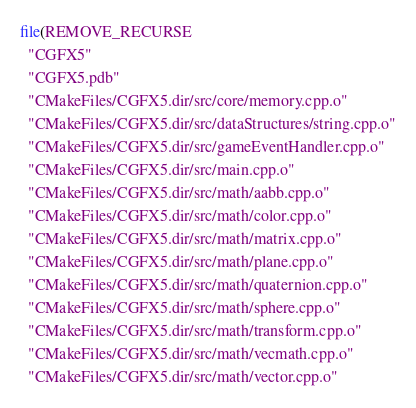Convert code to text. <code><loc_0><loc_0><loc_500><loc_500><_CMake_>file(REMOVE_RECURSE
  "CGFX5"
  "CGFX5.pdb"
  "CMakeFiles/CGFX5.dir/src/core/memory.cpp.o"
  "CMakeFiles/CGFX5.dir/src/dataStructures/string.cpp.o"
  "CMakeFiles/CGFX5.dir/src/gameEventHandler.cpp.o"
  "CMakeFiles/CGFX5.dir/src/main.cpp.o"
  "CMakeFiles/CGFX5.dir/src/math/aabb.cpp.o"
  "CMakeFiles/CGFX5.dir/src/math/color.cpp.o"
  "CMakeFiles/CGFX5.dir/src/math/matrix.cpp.o"
  "CMakeFiles/CGFX5.dir/src/math/plane.cpp.o"
  "CMakeFiles/CGFX5.dir/src/math/quaternion.cpp.o"
  "CMakeFiles/CGFX5.dir/src/math/sphere.cpp.o"
  "CMakeFiles/CGFX5.dir/src/math/transform.cpp.o"
  "CMakeFiles/CGFX5.dir/src/math/vecmath.cpp.o"
  "CMakeFiles/CGFX5.dir/src/math/vector.cpp.o"</code> 